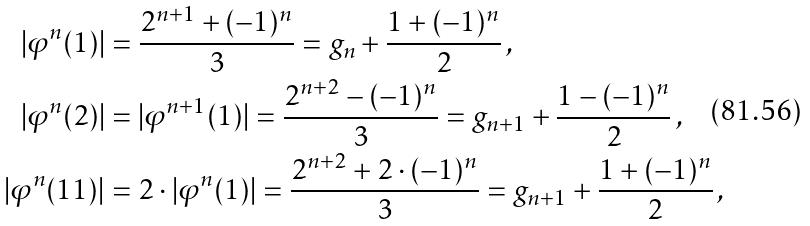<formula> <loc_0><loc_0><loc_500><loc_500>| \varphi ^ { n } ( 1 ) | & = \frac { 2 ^ { n + 1 } + ( - 1 ) ^ { n } } { 3 } = g _ { n } + \frac { 1 + ( - 1 ) ^ { n } } { 2 } \, , \\ | \varphi ^ { n } ( 2 ) | & = | \varphi ^ { n + 1 } ( 1 ) | = \frac { 2 ^ { n + 2 } - ( - 1 ) ^ { n } } { 3 } = g _ { n + 1 } + \frac { 1 - ( - 1 ) ^ { n } } { 2 } \, , \\ | \varphi ^ { n } ( 1 1 ) | & = 2 \cdot | \varphi ^ { n } ( 1 ) | = \frac { 2 ^ { n + 2 } + 2 \cdot ( - 1 ) ^ { n } } { 3 } = g _ { n + 1 } + \frac { 1 + ( - 1 ) ^ { n } } { 2 } \, ,</formula> 